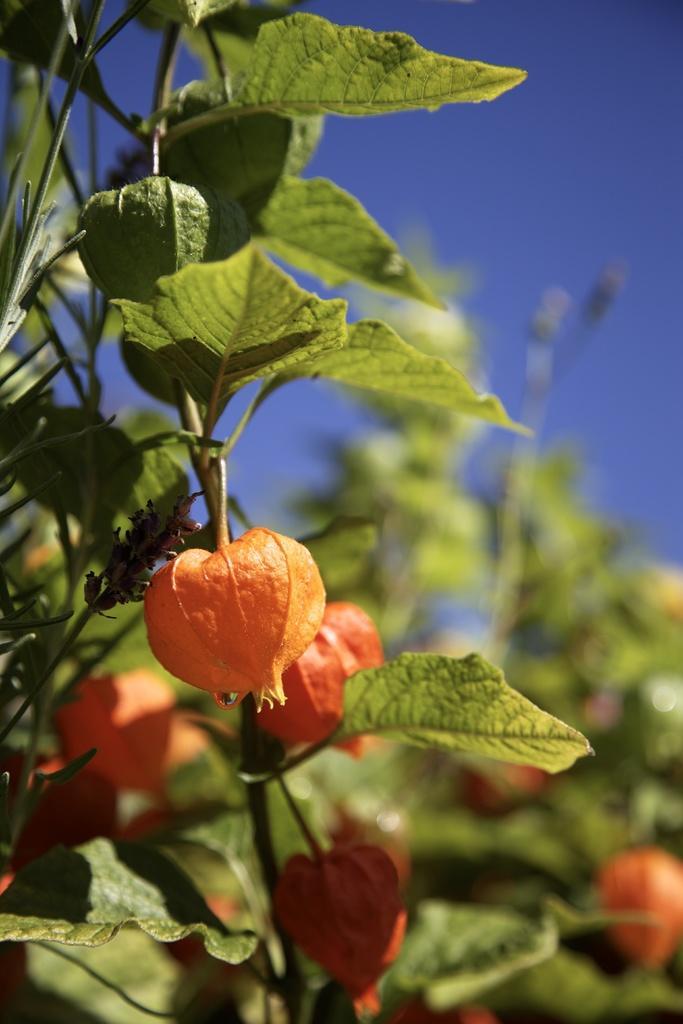How would you summarize this image in a sentence or two? In this picture there are orange color flowers on the plants. At the top there is sky. 